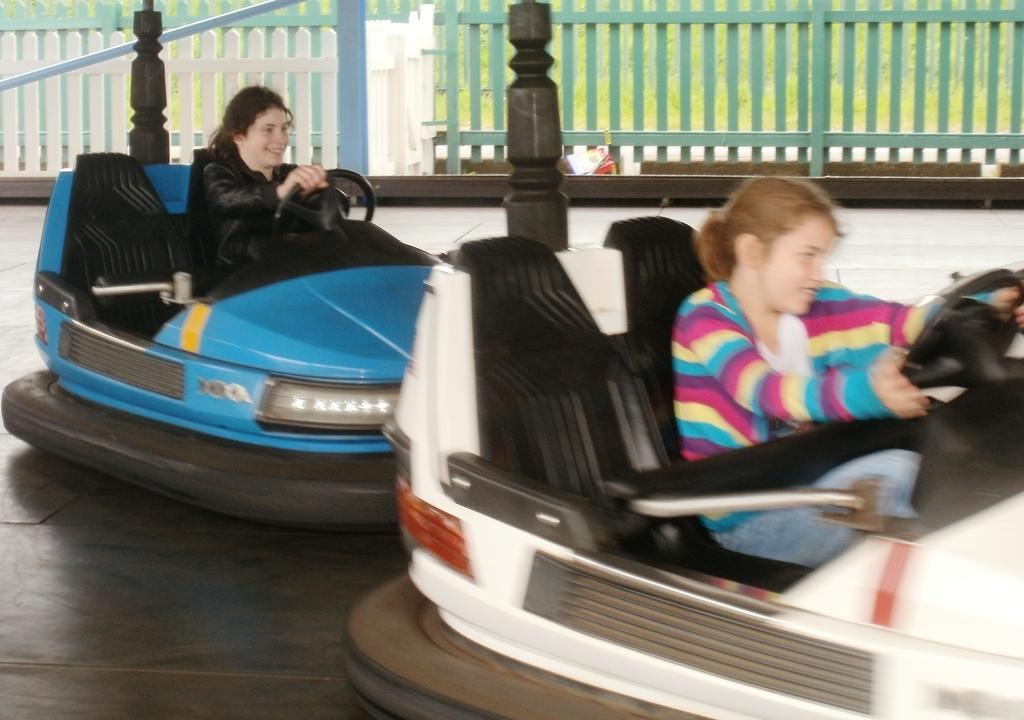What are the kids doing in the image? The kids are playing in the image, specifically with racing cars. What type of toys are the kids using for play? The kids are playing with racing cars. How much space is available for the kids to play in the image? The playing area is small. What kind of barrier surrounds the playing area? There is a wooden fencing around the playing area. Who else is participating in the playtime in the image? Two women are riding toy cars in the image. What type of request can be seen written on the space station in the image? There is no space station present in the image, and therefore no requests can be seen. 